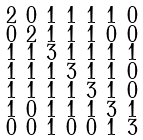Convert formula to latex. <formula><loc_0><loc_0><loc_500><loc_500>\begin{smallmatrix} 2 & 0 & 1 & 1 & 1 & 1 & 0 \\ 0 & 2 & 1 & 1 & 1 & 0 & 0 \\ 1 & 1 & 3 & 1 & 1 & 1 & 1 \\ 1 & 1 & 1 & 3 & 1 & 1 & 0 \\ 1 & 1 & 1 & 1 & 3 & 1 & 0 \\ 1 & 0 & 1 & 1 & 1 & 3 & 1 \\ 0 & 0 & 1 & 0 & 0 & 1 & 3 \end{smallmatrix}</formula> 